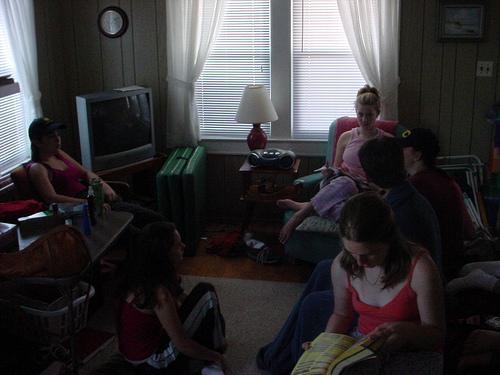What kind of pants is the girl in pink wearing?
Make your selection and explain in format: 'Answer: answer
Rationale: rationale.'
Options: Capris, leggings, pajama bottoms, jeans. Answer: pajama bottoms.
Rationale: The girl in pink is wearing relaxed clothing meant for sleeping. 